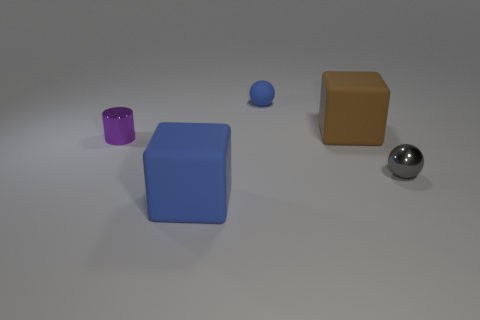Add 2 tiny green metal things. How many objects exist? 7 Subtract 1 spheres. How many spheres are left? 1 Subtract all blue cubes. How many cubes are left? 1 Subtract all red cylinders. How many blue cubes are left? 1 Subtract all gray things. Subtract all metallic balls. How many objects are left? 3 Add 5 big matte objects. How many big matte objects are left? 7 Add 5 brown spheres. How many brown spheres exist? 5 Subtract 0 gray blocks. How many objects are left? 5 Subtract all blocks. How many objects are left? 3 Subtract all brown spheres. Subtract all yellow blocks. How many spheres are left? 2 